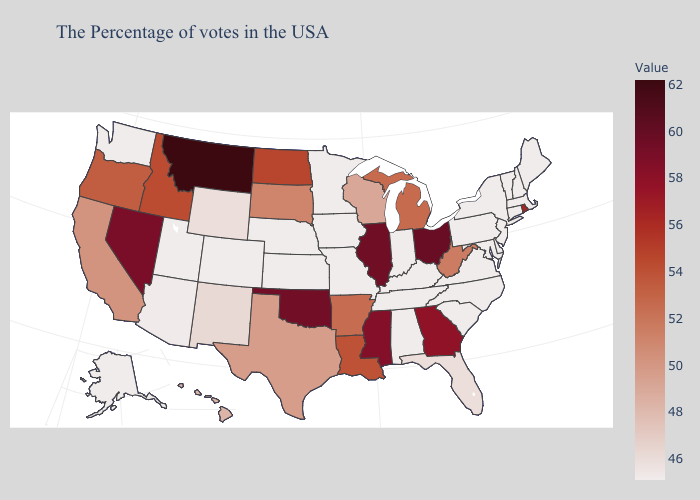Which states have the lowest value in the Northeast?
Be succinct. Maine, Massachusetts, New Hampshire, Vermont, Connecticut, New York, New Jersey, Pennsylvania. Among the states that border Nevada , which have the lowest value?
Keep it brief. Utah. Does Rhode Island have the highest value in the USA?
Give a very brief answer. No. Does Washington have the highest value in the USA?
Keep it brief. No. Is the legend a continuous bar?
Write a very short answer. Yes. Does the map have missing data?
Write a very short answer. No. Does Vermont have the lowest value in the Northeast?
Answer briefly. Yes. Among the states that border South Dakota , does Montana have the highest value?
Quick response, please. Yes. 